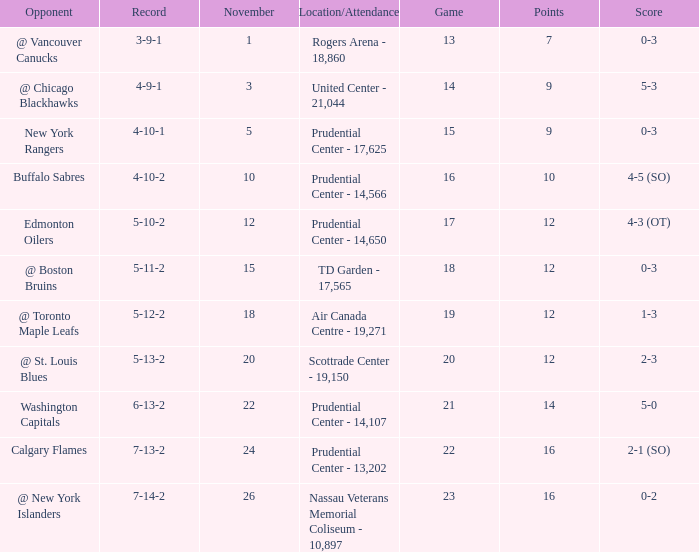What is the total number of locations that had a score of 1-3? 1.0. 